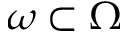<formula> <loc_0><loc_0><loc_500><loc_500>\omega \subset \Omega</formula> 